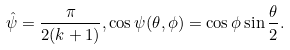<formula> <loc_0><loc_0><loc_500><loc_500>\hat { \psi } = \frac { \pi } { 2 ( k + 1 ) } , \cos \psi ( \theta , \phi ) = \cos \phi \sin \frac { \theta } { 2 } .</formula> 